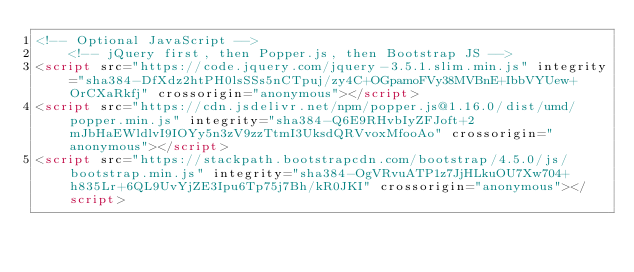<code> <loc_0><loc_0><loc_500><loc_500><_HTML_><!-- Optional JavaScript -->
    <!-- jQuery first, then Popper.js, then Bootstrap JS -->
<script src="https://code.jquery.com/jquery-3.5.1.slim.min.js" integrity="sha384-DfXdz2htPH0lsSSs5nCTpuj/zy4C+OGpamoFVy38MVBnE+IbbVYUew+OrCXaRkfj" crossorigin="anonymous"></script>
<script src="https://cdn.jsdelivr.net/npm/popper.js@1.16.0/dist/umd/popper.min.js" integrity="sha384-Q6E9RHvbIyZFJoft+2mJbHaEWldlvI9IOYy5n3zV9zzTtmI3UksdQRVvoxMfooAo" crossorigin="anonymous"></script>
<script src="https://stackpath.bootstrapcdn.com/bootstrap/4.5.0/js/bootstrap.min.js" integrity="sha384-OgVRvuATP1z7JjHLkuOU7Xw704+h835Lr+6QL9UvYjZE3Ipu6Tp75j7Bh/kR0JKI" crossorigin="anonymous"></script></code> 